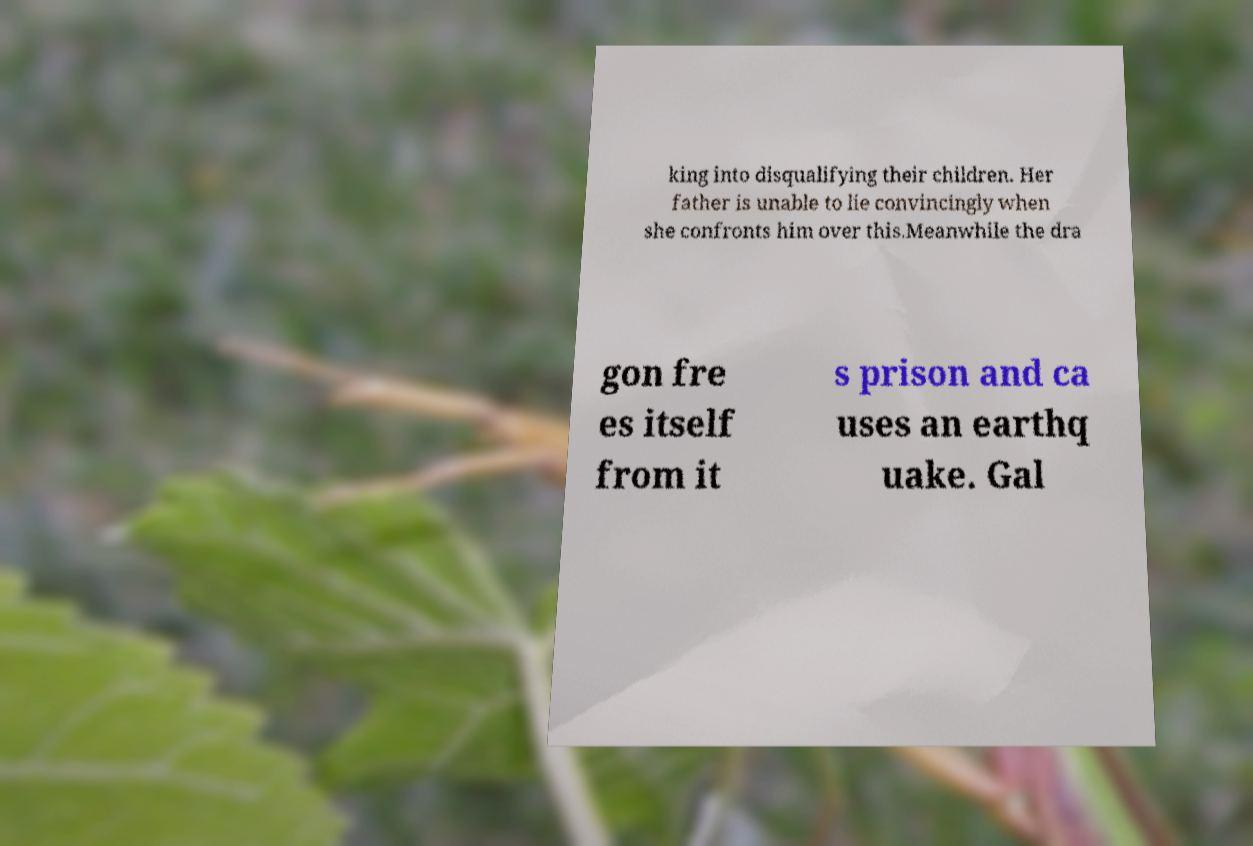Could you assist in decoding the text presented in this image and type it out clearly? king into disqualifying their children. Her father is unable to lie convincingly when she confronts him over this.Meanwhile the dra gon fre es itself from it s prison and ca uses an earthq uake. Gal 